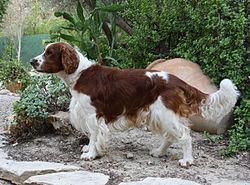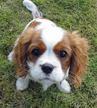The first image is the image on the left, the second image is the image on the right. For the images shown, is this caption "Each image shows an orange-and-white spaniel on green grass, and the left image shows a dog sitting upright with body angled leftward." true? Answer yes or no. No. The first image is the image on the left, the second image is the image on the right. Evaluate the accuracy of this statement regarding the images: "One dog is laying down.". Is it true? Answer yes or no. No. 